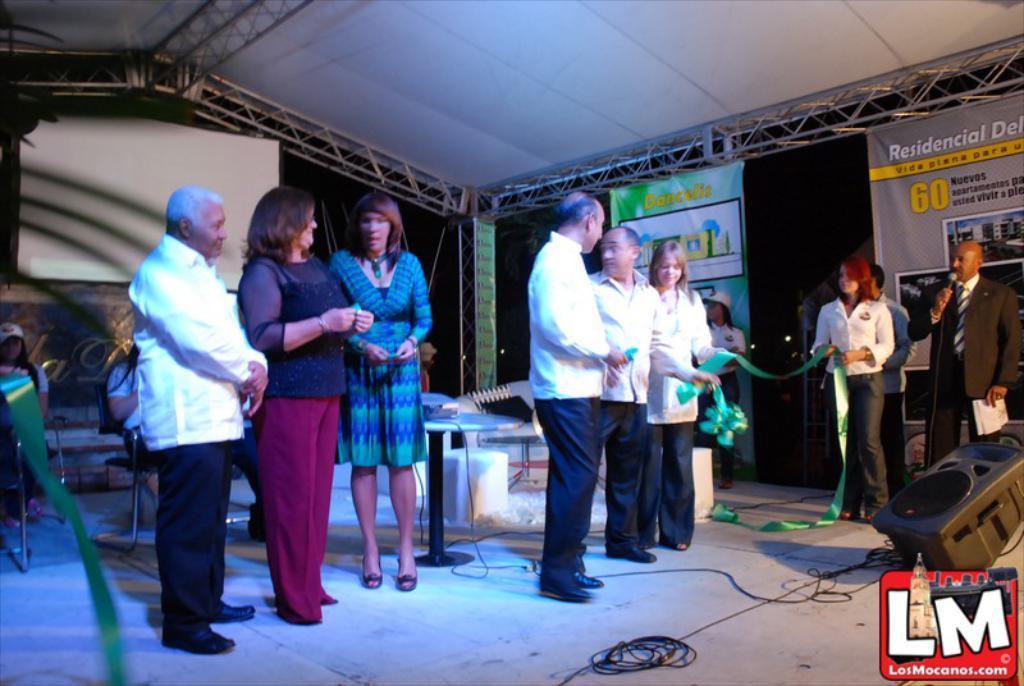Describe this image in one or two sentences. In this image in the center there are persons standing, there is a table and on the table there is an object, there are persons sitting and there are ribbons which are green in colour. On the right side in the front there is a speaker and there are wires and there is a person standing and holding a mic in his hand and speaking and there are banners with some text written on it. In the background there is a white board and there are black colour curtains and there are stands. 